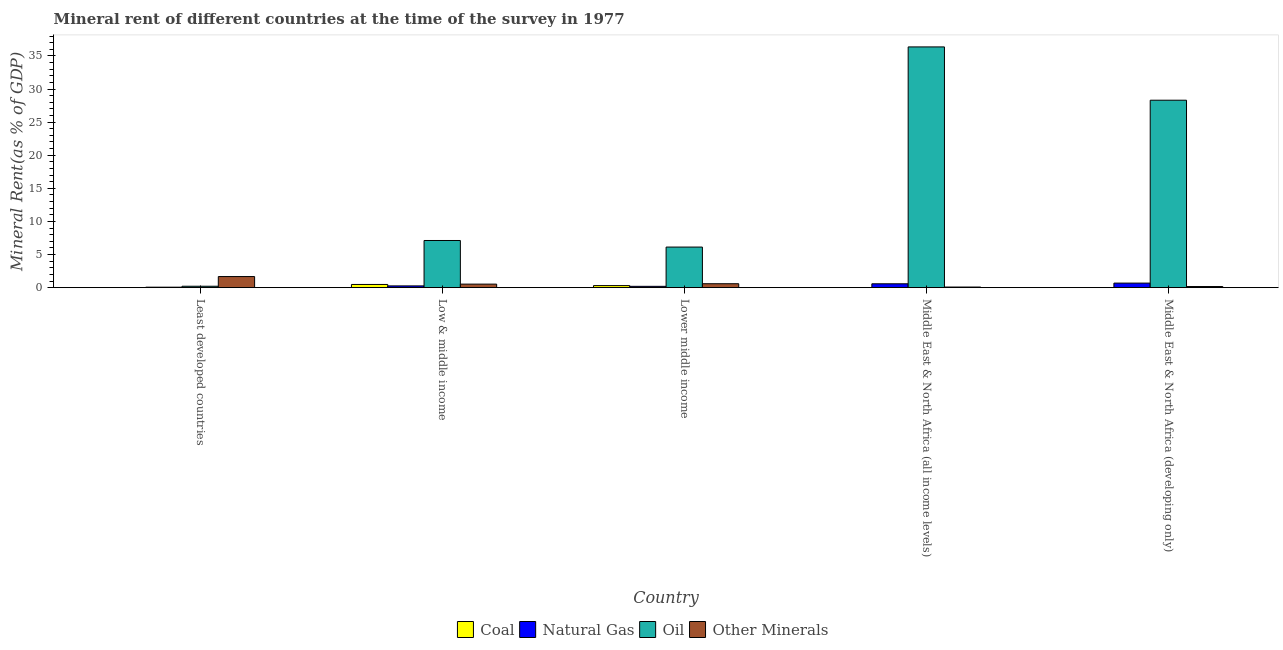How many bars are there on the 2nd tick from the left?
Your answer should be very brief. 4. In how many cases, is the number of bars for a given country not equal to the number of legend labels?
Your answer should be very brief. 0. What is the  rent of other minerals in Middle East & North Africa (developing only)?
Offer a terse response. 0.17. Across all countries, what is the maximum  rent of other minerals?
Offer a very short reply. 1.68. Across all countries, what is the minimum coal rent?
Keep it short and to the point. 0.01. In which country was the oil rent maximum?
Ensure brevity in your answer.  Middle East & North Africa (all income levels). In which country was the coal rent minimum?
Offer a terse response. Middle East & North Africa (all income levels). What is the total oil rent in the graph?
Your answer should be very brief. 78.14. What is the difference between the oil rent in Least developed countries and that in Low & middle income?
Provide a succinct answer. -6.91. What is the difference between the  rent of other minerals in Lower middle income and the natural gas rent in Low & middle income?
Make the answer very short. 0.33. What is the average oil rent per country?
Offer a terse response. 15.63. What is the difference between the coal rent and oil rent in Low & middle income?
Provide a succinct answer. -6.64. What is the ratio of the oil rent in Middle East & North Africa (all income levels) to that in Middle East & North Africa (developing only)?
Provide a short and direct response. 1.28. Is the  rent of other minerals in Least developed countries less than that in Low & middle income?
Ensure brevity in your answer.  No. Is the difference between the natural gas rent in Least developed countries and Low & middle income greater than the difference between the oil rent in Least developed countries and Low & middle income?
Provide a short and direct response. Yes. What is the difference between the highest and the second highest natural gas rent?
Provide a short and direct response. 0.1. What is the difference between the highest and the lowest coal rent?
Offer a very short reply. 0.48. In how many countries, is the oil rent greater than the average oil rent taken over all countries?
Keep it short and to the point. 2. Is the sum of the natural gas rent in Low & middle income and Middle East & North Africa (developing only) greater than the maximum oil rent across all countries?
Make the answer very short. No. What does the 1st bar from the left in Middle East & North Africa (all income levels) represents?
Offer a very short reply. Coal. What does the 4th bar from the right in Lower middle income represents?
Provide a short and direct response. Coal. How many bars are there?
Make the answer very short. 20. Are all the bars in the graph horizontal?
Provide a succinct answer. No. How many countries are there in the graph?
Give a very brief answer. 5. Are the values on the major ticks of Y-axis written in scientific E-notation?
Your answer should be compact. No. Does the graph contain grids?
Provide a short and direct response. No. What is the title of the graph?
Your response must be concise. Mineral rent of different countries at the time of the survey in 1977. What is the label or title of the Y-axis?
Your answer should be very brief. Mineral Rent(as % of GDP). What is the Mineral Rent(as % of GDP) in Coal in Least developed countries?
Your answer should be compact. 0.01. What is the Mineral Rent(as % of GDP) in Natural Gas in Least developed countries?
Provide a short and direct response. 0.07. What is the Mineral Rent(as % of GDP) in Oil in Least developed countries?
Provide a short and direct response. 0.21. What is the Mineral Rent(as % of GDP) of Other Minerals in Least developed countries?
Keep it short and to the point. 1.68. What is the Mineral Rent(as % of GDP) of Coal in Low & middle income?
Provide a succinct answer. 0.48. What is the Mineral Rent(as % of GDP) of Natural Gas in Low & middle income?
Your response must be concise. 0.27. What is the Mineral Rent(as % of GDP) of Oil in Low & middle income?
Give a very brief answer. 7.12. What is the Mineral Rent(as % of GDP) of Other Minerals in Low & middle income?
Make the answer very short. 0.54. What is the Mineral Rent(as % of GDP) of Coal in Lower middle income?
Your response must be concise. 0.31. What is the Mineral Rent(as % of GDP) in Natural Gas in Lower middle income?
Provide a short and direct response. 0.2. What is the Mineral Rent(as % of GDP) of Oil in Lower middle income?
Your response must be concise. 6.13. What is the Mineral Rent(as % of GDP) of Other Minerals in Lower middle income?
Offer a terse response. 0.59. What is the Mineral Rent(as % of GDP) of Coal in Middle East & North Africa (all income levels)?
Your response must be concise. 0.01. What is the Mineral Rent(as % of GDP) in Natural Gas in Middle East & North Africa (all income levels)?
Keep it short and to the point. 0.59. What is the Mineral Rent(as % of GDP) of Oil in Middle East & North Africa (all income levels)?
Your answer should be very brief. 36.36. What is the Mineral Rent(as % of GDP) of Other Minerals in Middle East & North Africa (all income levels)?
Your response must be concise. 0.09. What is the Mineral Rent(as % of GDP) in Coal in Middle East & North Africa (developing only)?
Offer a terse response. 0.01. What is the Mineral Rent(as % of GDP) in Natural Gas in Middle East & North Africa (developing only)?
Offer a terse response. 0.69. What is the Mineral Rent(as % of GDP) in Oil in Middle East & North Africa (developing only)?
Offer a very short reply. 28.31. What is the Mineral Rent(as % of GDP) of Other Minerals in Middle East & North Africa (developing only)?
Offer a terse response. 0.17. Across all countries, what is the maximum Mineral Rent(as % of GDP) of Coal?
Your answer should be compact. 0.48. Across all countries, what is the maximum Mineral Rent(as % of GDP) in Natural Gas?
Offer a very short reply. 0.69. Across all countries, what is the maximum Mineral Rent(as % of GDP) in Oil?
Offer a terse response. 36.36. Across all countries, what is the maximum Mineral Rent(as % of GDP) of Other Minerals?
Provide a short and direct response. 1.68. Across all countries, what is the minimum Mineral Rent(as % of GDP) of Coal?
Ensure brevity in your answer.  0.01. Across all countries, what is the minimum Mineral Rent(as % of GDP) of Natural Gas?
Keep it short and to the point. 0.07. Across all countries, what is the minimum Mineral Rent(as % of GDP) of Oil?
Your response must be concise. 0.21. Across all countries, what is the minimum Mineral Rent(as % of GDP) of Other Minerals?
Offer a terse response. 0.09. What is the total Mineral Rent(as % of GDP) in Coal in the graph?
Ensure brevity in your answer.  0.83. What is the total Mineral Rent(as % of GDP) in Natural Gas in the graph?
Provide a succinct answer. 1.82. What is the total Mineral Rent(as % of GDP) in Oil in the graph?
Offer a very short reply. 78.14. What is the total Mineral Rent(as % of GDP) of Other Minerals in the graph?
Your response must be concise. 3.07. What is the difference between the Mineral Rent(as % of GDP) in Coal in Least developed countries and that in Low & middle income?
Your response must be concise. -0.47. What is the difference between the Mineral Rent(as % of GDP) in Natural Gas in Least developed countries and that in Low & middle income?
Provide a succinct answer. -0.19. What is the difference between the Mineral Rent(as % of GDP) of Oil in Least developed countries and that in Low & middle income?
Your response must be concise. -6.91. What is the difference between the Mineral Rent(as % of GDP) in Other Minerals in Least developed countries and that in Low & middle income?
Offer a very short reply. 1.14. What is the difference between the Mineral Rent(as % of GDP) in Coal in Least developed countries and that in Lower middle income?
Provide a succinct answer. -0.3. What is the difference between the Mineral Rent(as % of GDP) of Natural Gas in Least developed countries and that in Lower middle income?
Offer a terse response. -0.13. What is the difference between the Mineral Rent(as % of GDP) of Oil in Least developed countries and that in Lower middle income?
Provide a succinct answer. -5.92. What is the difference between the Mineral Rent(as % of GDP) of Other Minerals in Least developed countries and that in Lower middle income?
Your answer should be very brief. 1.08. What is the difference between the Mineral Rent(as % of GDP) of Coal in Least developed countries and that in Middle East & North Africa (all income levels)?
Provide a short and direct response. 0. What is the difference between the Mineral Rent(as % of GDP) of Natural Gas in Least developed countries and that in Middle East & North Africa (all income levels)?
Provide a succinct answer. -0.51. What is the difference between the Mineral Rent(as % of GDP) in Oil in Least developed countries and that in Middle East & North Africa (all income levels)?
Ensure brevity in your answer.  -36.15. What is the difference between the Mineral Rent(as % of GDP) in Other Minerals in Least developed countries and that in Middle East & North Africa (all income levels)?
Keep it short and to the point. 1.58. What is the difference between the Mineral Rent(as % of GDP) in Coal in Least developed countries and that in Middle East & North Africa (developing only)?
Your answer should be compact. -0. What is the difference between the Mineral Rent(as % of GDP) of Natural Gas in Least developed countries and that in Middle East & North Africa (developing only)?
Your response must be concise. -0.61. What is the difference between the Mineral Rent(as % of GDP) in Oil in Least developed countries and that in Middle East & North Africa (developing only)?
Offer a terse response. -28.1. What is the difference between the Mineral Rent(as % of GDP) of Other Minerals in Least developed countries and that in Middle East & North Africa (developing only)?
Your answer should be very brief. 1.51. What is the difference between the Mineral Rent(as % of GDP) in Coal in Low & middle income and that in Lower middle income?
Your response must be concise. 0.17. What is the difference between the Mineral Rent(as % of GDP) of Natural Gas in Low & middle income and that in Lower middle income?
Your answer should be compact. 0.07. What is the difference between the Mineral Rent(as % of GDP) of Other Minerals in Low & middle income and that in Lower middle income?
Ensure brevity in your answer.  -0.06. What is the difference between the Mineral Rent(as % of GDP) of Coal in Low & middle income and that in Middle East & North Africa (all income levels)?
Keep it short and to the point. 0.48. What is the difference between the Mineral Rent(as % of GDP) of Natural Gas in Low & middle income and that in Middle East & North Africa (all income levels)?
Keep it short and to the point. -0.32. What is the difference between the Mineral Rent(as % of GDP) of Oil in Low & middle income and that in Middle East & North Africa (all income levels)?
Keep it short and to the point. -29.24. What is the difference between the Mineral Rent(as % of GDP) in Other Minerals in Low & middle income and that in Middle East & North Africa (all income levels)?
Your response must be concise. 0.44. What is the difference between the Mineral Rent(as % of GDP) of Coal in Low & middle income and that in Middle East & North Africa (developing only)?
Your response must be concise. 0.47. What is the difference between the Mineral Rent(as % of GDP) of Natural Gas in Low & middle income and that in Middle East & North Africa (developing only)?
Give a very brief answer. -0.42. What is the difference between the Mineral Rent(as % of GDP) of Oil in Low & middle income and that in Middle East & North Africa (developing only)?
Offer a terse response. -21.19. What is the difference between the Mineral Rent(as % of GDP) of Other Minerals in Low & middle income and that in Middle East & North Africa (developing only)?
Ensure brevity in your answer.  0.37. What is the difference between the Mineral Rent(as % of GDP) in Coal in Lower middle income and that in Middle East & North Africa (all income levels)?
Ensure brevity in your answer.  0.31. What is the difference between the Mineral Rent(as % of GDP) of Natural Gas in Lower middle income and that in Middle East & North Africa (all income levels)?
Give a very brief answer. -0.38. What is the difference between the Mineral Rent(as % of GDP) in Oil in Lower middle income and that in Middle East & North Africa (all income levels)?
Your answer should be compact. -30.23. What is the difference between the Mineral Rent(as % of GDP) of Other Minerals in Lower middle income and that in Middle East & North Africa (all income levels)?
Your response must be concise. 0.5. What is the difference between the Mineral Rent(as % of GDP) of Coal in Lower middle income and that in Middle East & North Africa (developing only)?
Provide a succinct answer. 0.3. What is the difference between the Mineral Rent(as % of GDP) in Natural Gas in Lower middle income and that in Middle East & North Africa (developing only)?
Offer a very short reply. -0.49. What is the difference between the Mineral Rent(as % of GDP) of Oil in Lower middle income and that in Middle East & North Africa (developing only)?
Ensure brevity in your answer.  -22.18. What is the difference between the Mineral Rent(as % of GDP) in Other Minerals in Lower middle income and that in Middle East & North Africa (developing only)?
Your answer should be very brief. 0.42. What is the difference between the Mineral Rent(as % of GDP) in Coal in Middle East & North Africa (all income levels) and that in Middle East & North Africa (developing only)?
Your answer should be very brief. -0.01. What is the difference between the Mineral Rent(as % of GDP) in Natural Gas in Middle East & North Africa (all income levels) and that in Middle East & North Africa (developing only)?
Provide a succinct answer. -0.1. What is the difference between the Mineral Rent(as % of GDP) in Oil in Middle East & North Africa (all income levels) and that in Middle East & North Africa (developing only)?
Your answer should be compact. 8.05. What is the difference between the Mineral Rent(as % of GDP) of Other Minerals in Middle East & North Africa (all income levels) and that in Middle East & North Africa (developing only)?
Ensure brevity in your answer.  -0.08. What is the difference between the Mineral Rent(as % of GDP) in Coal in Least developed countries and the Mineral Rent(as % of GDP) in Natural Gas in Low & middle income?
Give a very brief answer. -0.26. What is the difference between the Mineral Rent(as % of GDP) of Coal in Least developed countries and the Mineral Rent(as % of GDP) of Oil in Low & middle income?
Your response must be concise. -7.11. What is the difference between the Mineral Rent(as % of GDP) in Coal in Least developed countries and the Mineral Rent(as % of GDP) in Other Minerals in Low & middle income?
Your answer should be very brief. -0.52. What is the difference between the Mineral Rent(as % of GDP) of Natural Gas in Least developed countries and the Mineral Rent(as % of GDP) of Oil in Low & middle income?
Ensure brevity in your answer.  -7.05. What is the difference between the Mineral Rent(as % of GDP) in Natural Gas in Least developed countries and the Mineral Rent(as % of GDP) in Other Minerals in Low & middle income?
Provide a succinct answer. -0.46. What is the difference between the Mineral Rent(as % of GDP) of Oil in Least developed countries and the Mineral Rent(as % of GDP) of Other Minerals in Low & middle income?
Offer a terse response. -0.32. What is the difference between the Mineral Rent(as % of GDP) in Coal in Least developed countries and the Mineral Rent(as % of GDP) in Natural Gas in Lower middle income?
Provide a short and direct response. -0.19. What is the difference between the Mineral Rent(as % of GDP) of Coal in Least developed countries and the Mineral Rent(as % of GDP) of Oil in Lower middle income?
Keep it short and to the point. -6.12. What is the difference between the Mineral Rent(as % of GDP) in Coal in Least developed countries and the Mineral Rent(as % of GDP) in Other Minerals in Lower middle income?
Offer a very short reply. -0.58. What is the difference between the Mineral Rent(as % of GDP) of Natural Gas in Least developed countries and the Mineral Rent(as % of GDP) of Oil in Lower middle income?
Make the answer very short. -6.06. What is the difference between the Mineral Rent(as % of GDP) of Natural Gas in Least developed countries and the Mineral Rent(as % of GDP) of Other Minerals in Lower middle income?
Your answer should be very brief. -0.52. What is the difference between the Mineral Rent(as % of GDP) of Oil in Least developed countries and the Mineral Rent(as % of GDP) of Other Minerals in Lower middle income?
Make the answer very short. -0.38. What is the difference between the Mineral Rent(as % of GDP) in Coal in Least developed countries and the Mineral Rent(as % of GDP) in Natural Gas in Middle East & North Africa (all income levels)?
Provide a short and direct response. -0.57. What is the difference between the Mineral Rent(as % of GDP) in Coal in Least developed countries and the Mineral Rent(as % of GDP) in Oil in Middle East & North Africa (all income levels)?
Provide a short and direct response. -36.35. What is the difference between the Mineral Rent(as % of GDP) of Coal in Least developed countries and the Mineral Rent(as % of GDP) of Other Minerals in Middle East & North Africa (all income levels)?
Provide a succinct answer. -0.08. What is the difference between the Mineral Rent(as % of GDP) of Natural Gas in Least developed countries and the Mineral Rent(as % of GDP) of Oil in Middle East & North Africa (all income levels)?
Offer a very short reply. -36.29. What is the difference between the Mineral Rent(as % of GDP) in Natural Gas in Least developed countries and the Mineral Rent(as % of GDP) in Other Minerals in Middle East & North Africa (all income levels)?
Give a very brief answer. -0.02. What is the difference between the Mineral Rent(as % of GDP) of Oil in Least developed countries and the Mineral Rent(as % of GDP) of Other Minerals in Middle East & North Africa (all income levels)?
Provide a short and direct response. 0.12. What is the difference between the Mineral Rent(as % of GDP) in Coal in Least developed countries and the Mineral Rent(as % of GDP) in Natural Gas in Middle East & North Africa (developing only)?
Your answer should be very brief. -0.68. What is the difference between the Mineral Rent(as % of GDP) of Coal in Least developed countries and the Mineral Rent(as % of GDP) of Oil in Middle East & North Africa (developing only)?
Give a very brief answer. -28.3. What is the difference between the Mineral Rent(as % of GDP) of Coal in Least developed countries and the Mineral Rent(as % of GDP) of Other Minerals in Middle East & North Africa (developing only)?
Provide a succinct answer. -0.16. What is the difference between the Mineral Rent(as % of GDP) of Natural Gas in Least developed countries and the Mineral Rent(as % of GDP) of Oil in Middle East & North Africa (developing only)?
Give a very brief answer. -28.24. What is the difference between the Mineral Rent(as % of GDP) in Natural Gas in Least developed countries and the Mineral Rent(as % of GDP) in Other Minerals in Middle East & North Africa (developing only)?
Give a very brief answer. -0.1. What is the difference between the Mineral Rent(as % of GDP) in Oil in Least developed countries and the Mineral Rent(as % of GDP) in Other Minerals in Middle East & North Africa (developing only)?
Ensure brevity in your answer.  0.04. What is the difference between the Mineral Rent(as % of GDP) of Coal in Low & middle income and the Mineral Rent(as % of GDP) of Natural Gas in Lower middle income?
Provide a short and direct response. 0.28. What is the difference between the Mineral Rent(as % of GDP) of Coal in Low & middle income and the Mineral Rent(as % of GDP) of Oil in Lower middle income?
Ensure brevity in your answer.  -5.65. What is the difference between the Mineral Rent(as % of GDP) in Coal in Low & middle income and the Mineral Rent(as % of GDP) in Other Minerals in Lower middle income?
Give a very brief answer. -0.11. What is the difference between the Mineral Rent(as % of GDP) in Natural Gas in Low & middle income and the Mineral Rent(as % of GDP) in Oil in Lower middle income?
Provide a short and direct response. -5.86. What is the difference between the Mineral Rent(as % of GDP) of Natural Gas in Low & middle income and the Mineral Rent(as % of GDP) of Other Minerals in Lower middle income?
Keep it short and to the point. -0.33. What is the difference between the Mineral Rent(as % of GDP) of Oil in Low & middle income and the Mineral Rent(as % of GDP) of Other Minerals in Lower middle income?
Ensure brevity in your answer.  6.53. What is the difference between the Mineral Rent(as % of GDP) in Coal in Low & middle income and the Mineral Rent(as % of GDP) in Natural Gas in Middle East & North Africa (all income levels)?
Offer a very short reply. -0.1. What is the difference between the Mineral Rent(as % of GDP) in Coal in Low & middle income and the Mineral Rent(as % of GDP) in Oil in Middle East & North Africa (all income levels)?
Make the answer very short. -35.88. What is the difference between the Mineral Rent(as % of GDP) of Coal in Low & middle income and the Mineral Rent(as % of GDP) of Other Minerals in Middle East & North Africa (all income levels)?
Make the answer very short. 0.39. What is the difference between the Mineral Rent(as % of GDP) of Natural Gas in Low & middle income and the Mineral Rent(as % of GDP) of Oil in Middle East & North Africa (all income levels)?
Your answer should be compact. -36.09. What is the difference between the Mineral Rent(as % of GDP) of Natural Gas in Low & middle income and the Mineral Rent(as % of GDP) of Other Minerals in Middle East & North Africa (all income levels)?
Ensure brevity in your answer.  0.17. What is the difference between the Mineral Rent(as % of GDP) of Oil in Low & middle income and the Mineral Rent(as % of GDP) of Other Minerals in Middle East & North Africa (all income levels)?
Your answer should be compact. 7.03. What is the difference between the Mineral Rent(as % of GDP) of Coal in Low & middle income and the Mineral Rent(as % of GDP) of Natural Gas in Middle East & North Africa (developing only)?
Your answer should be very brief. -0.2. What is the difference between the Mineral Rent(as % of GDP) in Coal in Low & middle income and the Mineral Rent(as % of GDP) in Oil in Middle East & North Africa (developing only)?
Make the answer very short. -27.83. What is the difference between the Mineral Rent(as % of GDP) in Coal in Low & middle income and the Mineral Rent(as % of GDP) in Other Minerals in Middle East & North Africa (developing only)?
Your answer should be compact. 0.31. What is the difference between the Mineral Rent(as % of GDP) in Natural Gas in Low & middle income and the Mineral Rent(as % of GDP) in Oil in Middle East & North Africa (developing only)?
Give a very brief answer. -28.04. What is the difference between the Mineral Rent(as % of GDP) in Natural Gas in Low & middle income and the Mineral Rent(as % of GDP) in Other Minerals in Middle East & North Africa (developing only)?
Offer a terse response. 0.1. What is the difference between the Mineral Rent(as % of GDP) in Oil in Low & middle income and the Mineral Rent(as % of GDP) in Other Minerals in Middle East & North Africa (developing only)?
Your response must be concise. 6.96. What is the difference between the Mineral Rent(as % of GDP) of Coal in Lower middle income and the Mineral Rent(as % of GDP) of Natural Gas in Middle East & North Africa (all income levels)?
Your answer should be compact. -0.27. What is the difference between the Mineral Rent(as % of GDP) in Coal in Lower middle income and the Mineral Rent(as % of GDP) in Oil in Middle East & North Africa (all income levels)?
Keep it short and to the point. -36.05. What is the difference between the Mineral Rent(as % of GDP) of Coal in Lower middle income and the Mineral Rent(as % of GDP) of Other Minerals in Middle East & North Africa (all income levels)?
Offer a terse response. 0.22. What is the difference between the Mineral Rent(as % of GDP) in Natural Gas in Lower middle income and the Mineral Rent(as % of GDP) in Oil in Middle East & North Africa (all income levels)?
Ensure brevity in your answer.  -36.16. What is the difference between the Mineral Rent(as % of GDP) of Natural Gas in Lower middle income and the Mineral Rent(as % of GDP) of Other Minerals in Middle East & North Africa (all income levels)?
Your answer should be compact. 0.11. What is the difference between the Mineral Rent(as % of GDP) in Oil in Lower middle income and the Mineral Rent(as % of GDP) in Other Minerals in Middle East & North Africa (all income levels)?
Ensure brevity in your answer.  6.03. What is the difference between the Mineral Rent(as % of GDP) of Coal in Lower middle income and the Mineral Rent(as % of GDP) of Natural Gas in Middle East & North Africa (developing only)?
Make the answer very short. -0.38. What is the difference between the Mineral Rent(as % of GDP) in Coal in Lower middle income and the Mineral Rent(as % of GDP) in Oil in Middle East & North Africa (developing only)?
Offer a very short reply. -28. What is the difference between the Mineral Rent(as % of GDP) of Coal in Lower middle income and the Mineral Rent(as % of GDP) of Other Minerals in Middle East & North Africa (developing only)?
Provide a succinct answer. 0.14. What is the difference between the Mineral Rent(as % of GDP) in Natural Gas in Lower middle income and the Mineral Rent(as % of GDP) in Oil in Middle East & North Africa (developing only)?
Make the answer very short. -28.11. What is the difference between the Mineral Rent(as % of GDP) of Natural Gas in Lower middle income and the Mineral Rent(as % of GDP) of Other Minerals in Middle East & North Africa (developing only)?
Make the answer very short. 0.03. What is the difference between the Mineral Rent(as % of GDP) of Oil in Lower middle income and the Mineral Rent(as % of GDP) of Other Minerals in Middle East & North Africa (developing only)?
Your response must be concise. 5.96. What is the difference between the Mineral Rent(as % of GDP) in Coal in Middle East & North Africa (all income levels) and the Mineral Rent(as % of GDP) in Natural Gas in Middle East & North Africa (developing only)?
Offer a terse response. -0.68. What is the difference between the Mineral Rent(as % of GDP) of Coal in Middle East & North Africa (all income levels) and the Mineral Rent(as % of GDP) of Oil in Middle East & North Africa (developing only)?
Offer a terse response. -28.3. What is the difference between the Mineral Rent(as % of GDP) in Coal in Middle East & North Africa (all income levels) and the Mineral Rent(as % of GDP) in Other Minerals in Middle East & North Africa (developing only)?
Your response must be concise. -0.16. What is the difference between the Mineral Rent(as % of GDP) of Natural Gas in Middle East & North Africa (all income levels) and the Mineral Rent(as % of GDP) of Oil in Middle East & North Africa (developing only)?
Offer a very short reply. -27.73. What is the difference between the Mineral Rent(as % of GDP) in Natural Gas in Middle East & North Africa (all income levels) and the Mineral Rent(as % of GDP) in Other Minerals in Middle East & North Africa (developing only)?
Ensure brevity in your answer.  0.42. What is the difference between the Mineral Rent(as % of GDP) of Oil in Middle East & North Africa (all income levels) and the Mineral Rent(as % of GDP) of Other Minerals in Middle East & North Africa (developing only)?
Your response must be concise. 36.19. What is the average Mineral Rent(as % of GDP) in Coal per country?
Make the answer very short. 0.17. What is the average Mineral Rent(as % of GDP) in Natural Gas per country?
Ensure brevity in your answer.  0.36. What is the average Mineral Rent(as % of GDP) in Oil per country?
Make the answer very short. 15.63. What is the average Mineral Rent(as % of GDP) of Other Minerals per country?
Provide a short and direct response. 0.61. What is the difference between the Mineral Rent(as % of GDP) of Coal and Mineral Rent(as % of GDP) of Natural Gas in Least developed countries?
Your answer should be very brief. -0.06. What is the difference between the Mineral Rent(as % of GDP) in Coal and Mineral Rent(as % of GDP) in Oil in Least developed countries?
Offer a terse response. -0.2. What is the difference between the Mineral Rent(as % of GDP) of Coal and Mineral Rent(as % of GDP) of Other Minerals in Least developed countries?
Your response must be concise. -1.67. What is the difference between the Mineral Rent(as % of GDP) in Natural Gas and Mineral Rent(as % of GDP) in Oil in Least developed countries?
Keep it short and to the point. -0.14. What is the difference between the Mineral Rent(as % of GDP) in Natural Gas and Mineral Rent(as % of GDP) in Other Minerals in Least developed countries?
Your answer should be very brief. -1.6. What is the difference between the Mineral Rent(as % of GDP) of Oil and Mineral Rent(as % of GDP) of Other Minerals in Least developed countries?
Your answer should be compact. -1.46. What is the difference between the Mineral Rent(as % of GDP) of Coal and Mineral Rent(as % of GDP) of Natural Gas in Low & middle income?
Offer a terse response. 0.22. What is the difference between the Mineral Rent(as % of GDP) in Coal and Mineral Rent(as % of GDP) in Oil in Low & middle income?
Ensure brevity in your answer.  -6.64. What is the difference between the Mineral Rent(as % of GDP) of Coal and Mineral Rent(as % of GDP) of Other Minerals in Low & middle income?
Your response must be concise. -0.05. What is the difference between the Mineral Rent(as % of GDP) of Natural Gas and Mineral Rent(as % of GDP) of Oil in Low & middle income?
Give a very brief answer. -6.86. What is the difference between the Mineral Rent(as % of GDP) in Natural Gas and Mineral Rent(as % of GDP) in Other Minerals in Low & middle income?
Offer a very short reply. -0.27. What is the difference between the Mineral Rent(as % of GDP) in Oil and Mineral Rent(as % of GDP) in Other Minerals in Low & middle income?
Your answer should be compact. 6.59. What is the difference between the Mineral Rent(as % of GDP) in Coal and Mineral Rent(as % of GDP) in Natural Gas in Lower middle income?
Keep it short and to the point. 0.11. What is the difference between the Mineral Rent(as % of GDP) in Coal and Mineral Rent(as % of GDP) in Oil in Lower middle income?
Make the answer very short. -5.82. What is the difference between the Mineral Rent(as % of GDP) of Coal and Mineral Rent(as % of GDP) of Other Minerals in Lower middle income?
Your answer should be compact. -0.28. What is the difference between the Mineral Rent(as % of GDP) in Natural Gas and Mineral Rent(as % of GDP) in Oil in Lower middle income?
Give a very brief answer. -5.93. What is the difference between the Mineral Rent(as % of GDP) in Natural Gas and Mineral Rent(as % of GDP) in Other Minerals in Lower middle income?
Provide a succinct answer. -0.39. What is the difference between the Mineral Rent(as % of GDP) in Oil and Mineral Rent(as % of GDP) in Other Minerals in Lower middle income?
Your response must be concise. 5.54. What is the difference between the Mineral Rent(as % of GDP) of Coal and Mineral Rent(as % of GDP) of Natural Gas in Middle East & North Africa (all income levels)?
Give a very brief answer. -0.58. What is the difference between the Mineral Rent(as % of GDP) of Coal and Mineral Rent(as % of GDP) of Oil in Middle East & North Africa (all income levels)?
Make the answer very short. -36.35. What is the difference between the Mineral Rent(as % of GDP) in Coal and Mineral Rent(as % of GDP) in Other Minerals in Middle East & North Africa (all income levels)?
Your answer should be very brief. -0.09. What is the difference between the Mineral Rent(as % of GDP) in Natural Gas and Mineral Rent(as % of GDP) in Oil in Middle East & North Africa (all income levels)?
Make the answer very short. -35.78. What is the difference between the Mineral Rent(as % of GDP) of Natural Gas and Mineral Rent(as % of GDP) of Other Minerals in Middle East & North Africa (all income levels)?
Offer a terse response. 0.49. What is the difference between the Mineral Rent(as % of GDP) of Oil and Mineral Rent(as % of GDP) of Other Minerals in Middle East & North Africa (all income levels)?
Make the answer very short. 36.27. What is the difference between the Mineral Rent(as % of GDP) of Coal and Mineral Rent(as % of GDP) of Natural Gas in Middle East & North Africa (developing only)?
Your answer should be very brief. -0.68. What is the difference between the Mineral Rent(as % of GDP) in Coal and Mineral Rent(as % of GDP) in Oil in Middle East & North Africa (developing only)?
Your answer should be very brief. -28.3. What is the difference between the Mineral Rent(as % of GDP) in Coal and Mineral Rent(as % of GDP) in Other Minerals in Middle East & North Africa (developing only)?
Your answer should be very brief. -0.16. What is the difference between the Mineral Rent(as % of GDP) in Natural Gas and Mineral Rent(as % of GDP) in Oil in Middle East & North Africa (developing only)?
Provide a succinct answer. -27.62. What is the difference between the Mineral Rent(as % of GDP) in Natural Gas and Mineral Rent(as % of GDP) in Other Minerals in Middle East & North Africa (developing only)?
Your answer should be compact. 0.52. What is the difference between the Mineral Rent(as % of GDP) in Oil and Mineral Rent(as % of GDP) in Other Minerals in Middle East & North Africa (developing only)?
Ensure brevity in your answer.  28.14. What is the ratio of the Mineral Rent(as % of GDP) in Coal in Least developed countries to that in Low & middle income?
Your response must be concise. 0.02. What is the ratio of the Mineral Rent(as % of GDP) in Natural Gas in Least developed countries to that in Low & middle income?
Your response must be concise. 0.28. What is the ratio of the Mineral Rent(as % of GDP) in Oil in Least developed countries to that in Low & middle income?
Your answer should be compact. 0.03. What is the ratio of the Mineral Rent(as % of GDP) in Other Minerals in Least developed countries to that in Low & middle income?
Give a very brief answer. 3.13. What is the ratio of the Mineral Rent(as % of GDP) of Coal in Least developed countries to that in Lower middle income?
Your answer should be compact. 0.04. What is the ratio of the Mineral Rent(as % of GDP) in Natural Gas in Least developed countries to that in Lower middle income?
Your answer should be compact. 0.37. What is the ratio of the Mineral Rent(as % of GDP) of Oil in Least developed countries to that in Lower middle income?
Your response must be concise. 0.03. What is the ratio of the Mineral Rent(as % of GDP) of Other Minerals in Least developed countries to that in Lower middle income?
Offer a very short reply. 2.83. What is the ratio of the Mineral Rent(as % of GDP) in Coal in Least developed countries to that in Middle East & North Africa (all income levels)?
Your answer should be very brief. 1.65. What is the ratio of the Mineral Rent(as % of GDP) of Natural Gas in Least developed countries to that in Middle East & North Africa (all income levels)?
Your response must be concise. 0.13. What is the ratio of the Mineral Rent(as % of GDP) in Oil in Least developed countries to that in Middle East & North Africa (all income levels)?
Ensure brevity in your answer.  0.01. What is the ratio of the Mineral Rent(as % of GDP) of Other Minerals in Least developed countries to that in Middle East & North Africa (all income levels)?
Ensure brevity in your answer.  17.71. What is the ratio of the Mineral Rent(as % of GDP) of Coal in Least developed countries to that in Middle East & North Africa (developing only)?
Give a very brief answer. 0.9. What is the ratio of the Mineral Rent(as % of GDP) of Natural Gas in Least developed countries to that in Middle East & North Africa (developing only)?
Offer a terse response. 0.11. What is the ratio of the Mineral Rent(as % of GDP) in Oil in Least developed countries to that in Middle East & North Africa (developing only)?
Offer a very short reply. 0.01. What is the ratio of the Mineral Rent(as % of GDP) of Other Minerals in Least developed countries to that in Middle East & North Africa (developing only)?
Your answer should be very brief. 9.88. What is the ratio of the Mineral Rent(as % of GDP) in Coal in Low & middle income to that in Lower middle income?
Your answer should be compact. 1.55. What is the ratio of the Mineral Rent(as % of GDP) in Natural Gas in Low & middle income to that in Lower middle income?
Your answer should be compact. 1.33. What is the ratio of the Mineral Rent(as % of GDP) in Oil in Low & middle income to that in Lower middle income?
Make the answer very short. 1.16. What is the ratio of the Mineral Rent(as % of GDP) of Other Minerals in Low & middle income to that in Lower middle income?
Offer a very short reply. 0.9. What is the ratio of the Mineral Rent(as % of GDP) of Coal in Low & middle income to that in Middle East & North Africa (all income levels)?
Give a very brief answer. 73.13. What is the ratio of the Mineral Rent(as % of GDP) of Natural Gas in Low & middle income to that in Middle East & North Africa (all income levels)?
Your answer should be compact. 0.46. What is the ratio of the Mineral Rent(as % of GDP) in Oil in Low & middle income to that in Middle East & North Africa (all income levels)?
Your response must be concise. 0.2. What is the ratio of the Mineral Rent(as % of GDP) of Other Minerals in Low & middle income to that in Middle East & North Africa (all income levels)?
Your answer should be very brief. 5.65. What is the ratio of the Mineral Rent(as % of GDP) of Coal in Low & middle income to that in Middle East & North Africa (developing only)?
Keep it short and to the point. 40.03. What is the ratio of the Mineral Rent(as % of GDP) in Natural Gas in Low & middle income to that in Middle East & North Africa (developing only)?
Your answer should be very brief. 0.39. What is the ratio of the Mineral Rent(as % of GDP) in Oil in Low & middle income to that in Middle East & North Africa (developing only)?
Your response must be concise. 0.25. What is the ratio of the Mineral Rent(as % of GDP) in Other Minerals in Low & middle income to that in Middle East & North Africa (developing only)?
Offer a terse response. 3.15. What is the ratio of the Mineral Rent(as % of GDP) in Coal in Lower middle income to that in Middle East & North Africa (all income levels)?
Your response must be concise. 47.13. What is the ratio of the Mineral Rent(as % of GDP) of Natural Gas in Lower middle income to that in Middle East & North Africa (all income levels)?
Provide a short and direct response. 0.34. What is the ratio of the Mineral Rent(as % of GDP) of Oil in Lower middle income to that in Middle East & North Africa (all income levels)?
Give a very brief answer. 0.17. What is the ratio of the Mineral Rent(as % of GDP) of Other Minerals in Lower middle income to that in Middle East & North Africa (all income levels)?
Give a very brief answer. 6.26. What is the ratio of the Mineral Rent(as % of GDP) of Coal in Lower middle income to that in Middle East & North Africa (developing only)?
Give a very brief answer. 25.8. What is the ratio of the Mineral Rent(as % of GDP) in Natural Gas in Lower middle income to that in Middle East & North Africa (developing only)?
Ensure brevity in your answer.  0.29. What is the ratio of the Mineral Rent(as % of GDP) in Oil in Lower middle income to that in Middle East & North Africa (developing only)?
Your answer should be compact. 0.22. What is the ratio of the Mineral Rent(as % of GDP) in Other Minerals in Lower middle income to that in Middle East & North Africa (developing only)?
Ensure brevity in your answer.  3.5. What is the ratio of the Mineral Rent(as % of GDP) of Coal in Middle East & North Africa (all income levels) to that in Middle East & North Africa (developing only)?
Offer a very short reply. 0.55. What is the ratio of the Mineral Rent(as % of GDP) in Natural Gas in Middle East & North Africa (all income levels) to that in Middle East & North Africa (developing only)?
Your answer should be very brief. 0.85. What is the ratio of the Mineral Rent(as % of GDP) of Oil in Middle East & North Africa (all income levels) to that in Middle East & North Africa (developing only)?
Your answer should be compact. 1.28. What is the ratio of the Mineral Rent(as % of GDP) of Other Minerals in Middle East & North Africa (all income levels) to that in Middle East & North Africa (developing only)?
Give a very brief answer. 0.56. What is the difference between the highest and the second highest Mineral Rent(as % of GDP) in Coal?
Offer a terse response. 0.17. What is the difference between the highest and the second highest Mineral Rent(as % of GDP) of Natural Gas?
Your answer should be compact. 0.1. What is the difference between the highest and the second highest Mineral Rent(as % of GDP) in Oil?
Ensure brevity in your answer.  8.05. What is the difference between the highest and the second highest Mineral Rent(as % of GDP) of Other Minerals?
Make the answer very short. 1.08. What is the difference between the highest and the lowest Mineral Rent(as % of GDP) in Coal?
Provide a succinct answer. 0.48. What is the difference between the highest and the lowest Mineral Rent(as % of GDP) in Natural Gas?
Make the answer very short. 0.61. What is the difference between the highest and the lowest Mineral Rent(as % of GDP) in Oil?
Make the answer very short. 36.15. What is the difference between the highest and the lowest Mineral Rent(as % of GDP) in Other Minerals?
Your answer should be very brief. 1.58. 